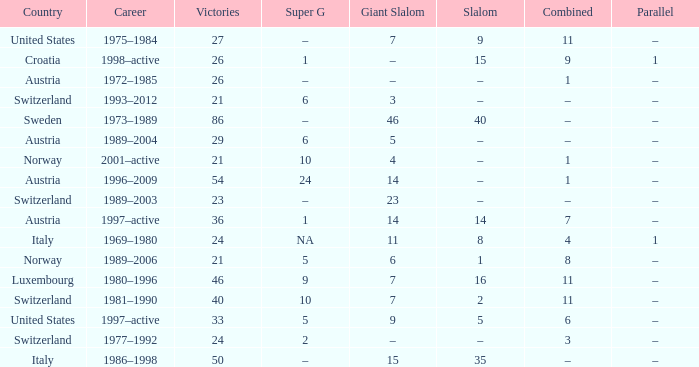What Super G has a Career of 1980–1996? 9.0. 